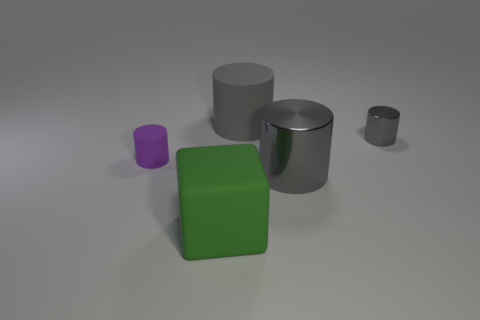What size is the rubber cylinder that is the same color as the small metallic cylinder?
Offer a very short reply. Large. Is there a red sphere made of the same material as the large block?
Offer a very short reply. No. What color is the large rubber cylinder?
Ensure brevity in your answer.  Gray. There is a shiny object behind the cylinder in front of the tiny object that is left of the gray rubber object; what size is it?
Provide a short and direct response. Small. What number of other objects are there of the same shape as the small shiny object?
Keep it short and to the point. 3. What is the color of the object that is left of the gray rubber cylinder and behind the large metal thing?
Provide a succinct answer. Purple. Is there any other thing that has the same size as the purple matte cylinder?
Your answer should be compact. Yes. Does the small cylinder to the left of the large green object have the same color as the cube?
Offer a very short reply. No. How many cubes are either gray objects or large gray rubber things?
Make the answer very short. 0. What is the shape of the matte object that is right of the large green matte cube?
Offer a terse response. Cylinder. 